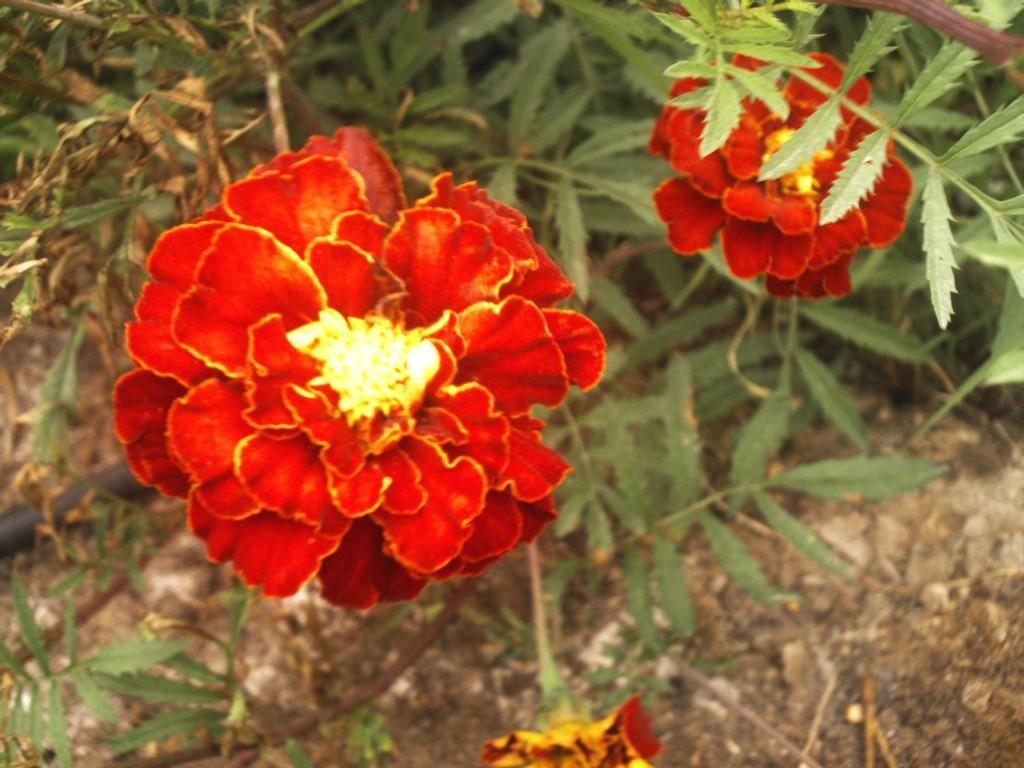How would you summarize this image in a sentence or two? In this picture I can see there are three flowers and it has red petals. There are few plants in the backdrop, there is soil and few stones on the floor. 